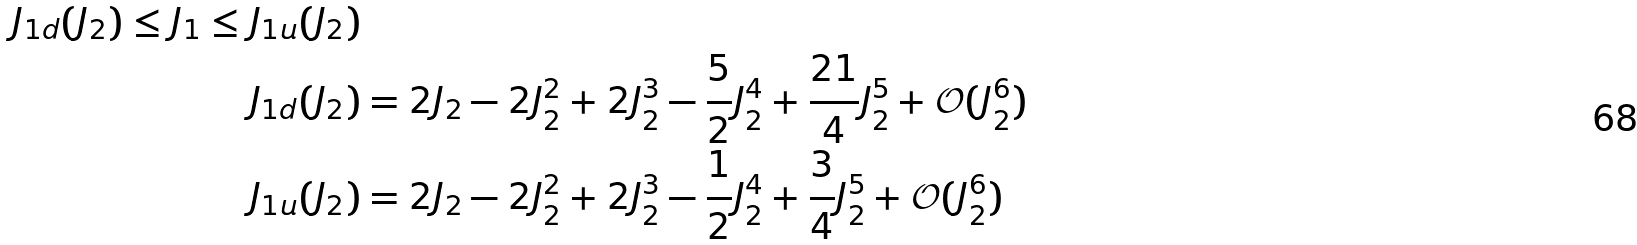Convert formula to latex. <formula><loc_0><loc_0><loc_500><loc_500>J _ { 1 d } ( J _ { 2 } ) \leq J _ { 1 } \leq J _ { 1 u } ( J _ { 2 } ) \\ J _ { 1 d } ( J _ { 2 } ) & = 2 J _ { 2 } - 2 J _ { 2 } ^ { 2 } + 2 J _ { 2 } ^ { 3 } - \frac { 5 } { 2 } J _ { 2 } ^ { 4 } + \frac { 2 1 } 4 J _ { 2 } ^ { 5 } + \mathcal { O } ( J _ { 2 } ^ { 6 } ) \\ J _ { 1 u } ( J _ { 2 } ) & = 2 J _ { 2 } - 2 J _ { 2 } ^ { 2 } + 2 J _ { 2 } ^ { 3 } - \frac { 1 } { 2 } J _ { 2 } ^ { 4 } + \frac { 3 } { 4 } J _ { 2 } ^ { 5 } + \mathcal { O } ( J _ { 2 } ^ { 6 } )</formula> 